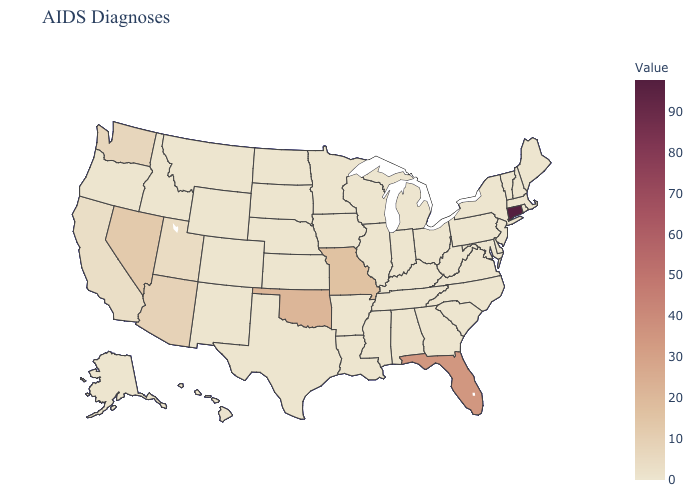Among the states that border Arkansas , which have the lowest value?
Answer briefly. Louisiana, Mississippi, Tennessee, Texas. Does Missouri have the lowest value in the MidWest?
Be succinct. No. Among the states that border Massachusetts , does New Hampshire have the lowest value?
Be succinct. Yes. Does New Mexico have the lowest value in the USA?
Be succinct. Yes. 